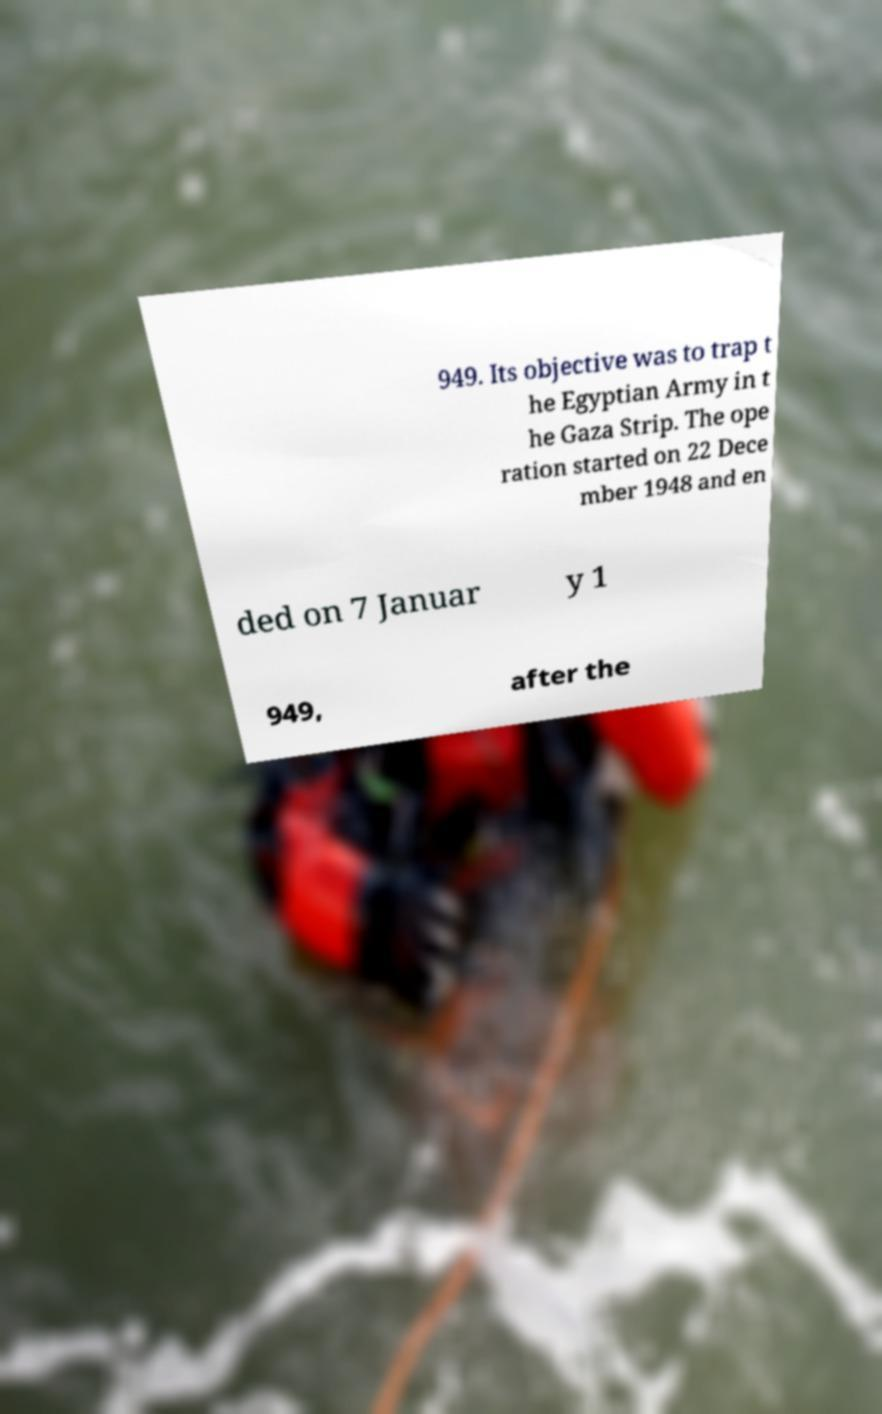For documentation purposes, I need the text within this image transcribed. Could you provide that? 949. Its objective was to trap t he Egyptian Army in t he Gaza Strip. The ope ration started on 22 Dece mber 1948 and en ded on 7 Januar y 1 949, after the 